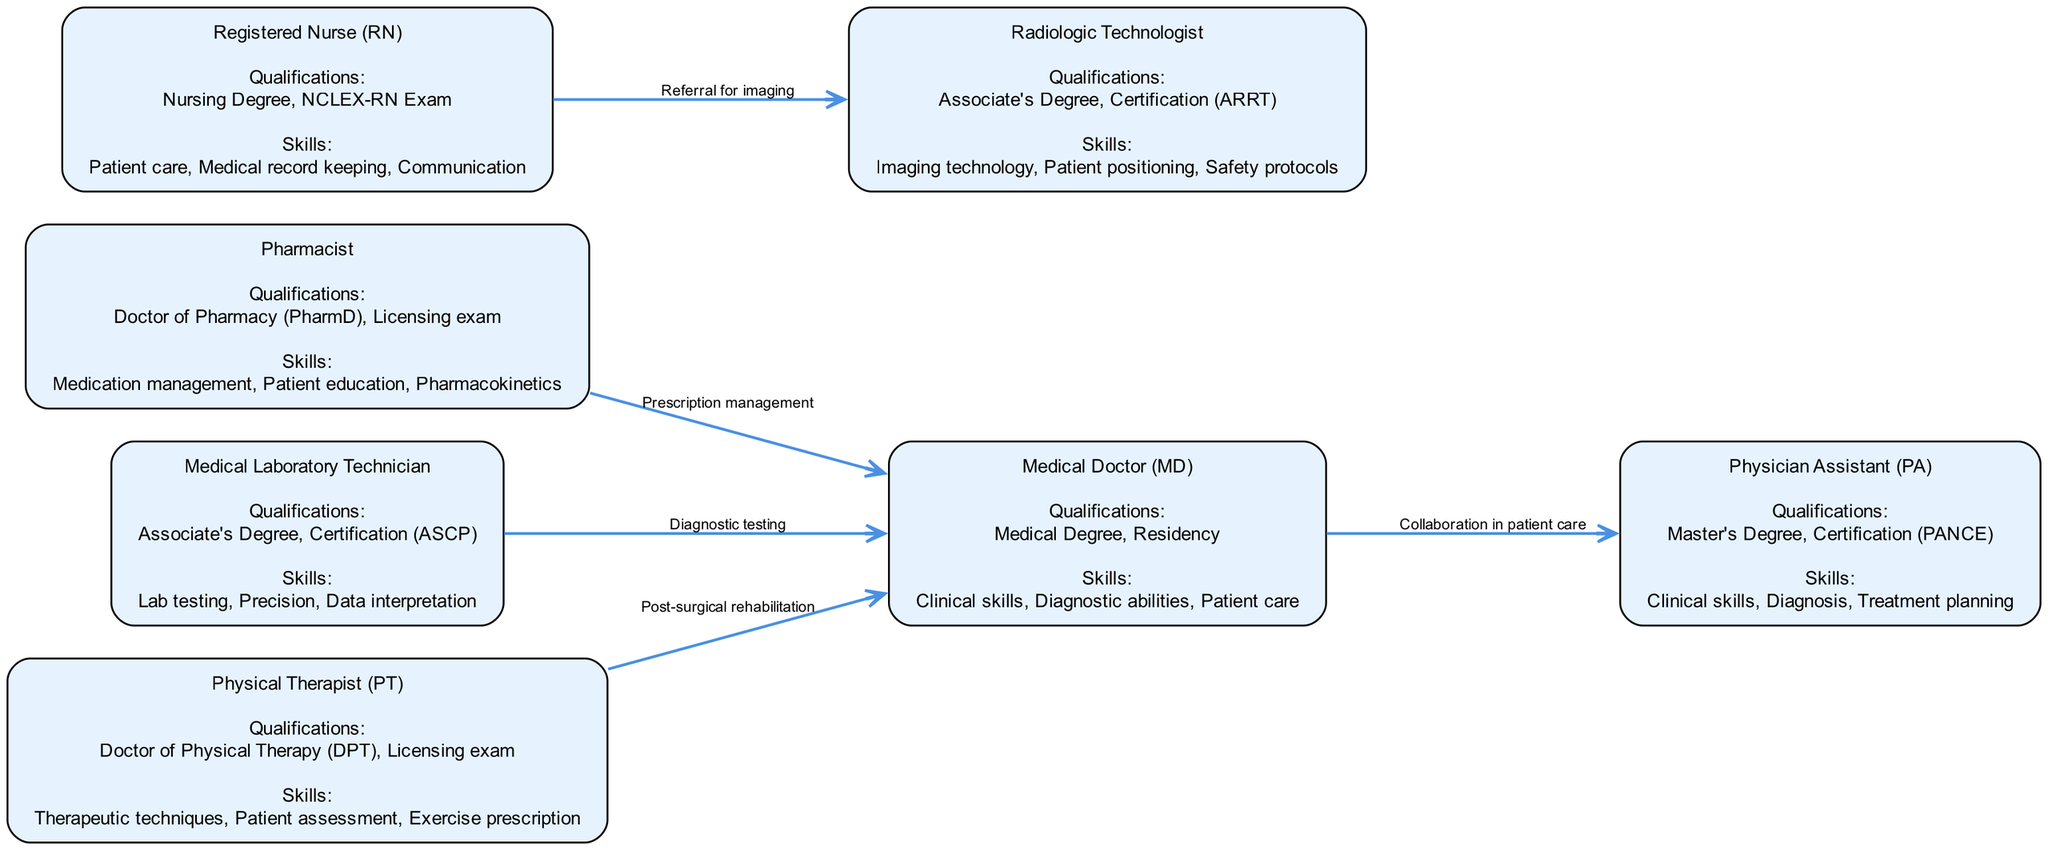What are the qualifications required to become a Medical Doctor? The diagram states that the qualifications for a Medical Doctor (MD) include a Medical Degree and Residency. This information can be found directly within the node labeled "Medical Doctor (MD)".
Answer: Medical Degree, Residency How many nodes are present in the diagram? The diagram contains nodes representing different medical career paths, which total to seven in number. This count can be verified by counting each distinct node listed in the data.
Answer: 7 What skills are highlighted for Registered Nurses? According to the diagram, the skills required for a Registered Nurse (RN) include Patient care, Medical record keeping, and Communication. This information is clearly outlined in the node for Registered Nurse.
Answer: Patient care, Medical record keeping, Communication Which career path collaborates with Physicians in patient care? The diagram indicates that the Physician Assistant (PA) collaborates with Medical Doctors (MD) in patient care. This is represented by an edge connecting the PA to the MD with a label describing their collaboration.
Answer: Physician Assistant (PA) What is the licensing requirement for a Physical Therapist? The diagram specifies that a Doctor of Physical Therapy (DPT) and a Licensing exam are needed to become a Physical Therapist (PT). This information can be extracted from the node associated with Physical Therapist in the diagram.
Answer: Doctor of Physical Therapy (DPT), Licensing exam Which career connects Radiologic Technologists and Registered Nurses? The diagram illustrates that Registered Nurses (RN) refer patients for imaging to Radiologic Technologists, indicated by an edge connecting these two nodes with a label describing the referral process.
Answer: Referral for imaging What role does a Pharmacist play in relation to a Medical Doctor? The diagram shows that Pharmacists manage prescriptions for Medical Doctors. This relationship is represented by the edge leading from the Pharmacist node to the Medical Doctor node, annotated with the corresponding activity.
Answer: Prescription management Which career requires a certification from ASCP? The Medical Laboratory Technician requires a certification from ASCP. This is explicitly mentioned in the qualifications within the Medical Laboratory Technician node in the diagram.
Answer: Certification (ASCP) 